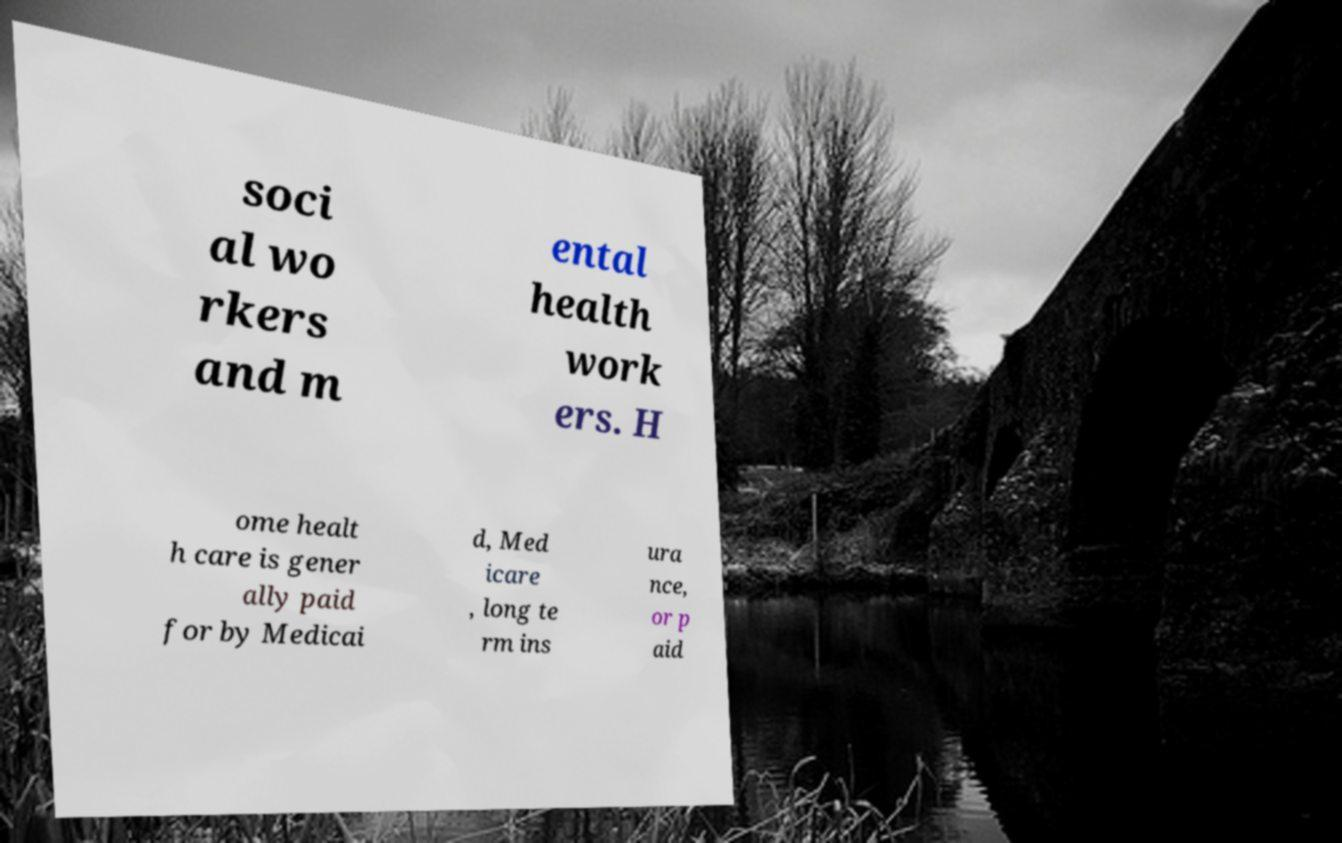Can you accurately transcribe the text from the provided image for me? soci al wo rkers and m ental health work ers. H ome healt h care is gener ally paid for by Medicai d, Med icare , long te rm ins ura nce, or p aid 